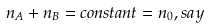<formula> <loc_0><loc_0><loc_500><loc_500>n _ { A } + n _ { B } = c o n s t a n t = n _ { 0 } , s a y</formula> 